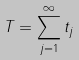Convert formula to latex. <formula><loc_0><loc_0><loc_500><loc_500>T = \sum _ { j = 1 } ^ { \infty } t _ { j }</formula> 